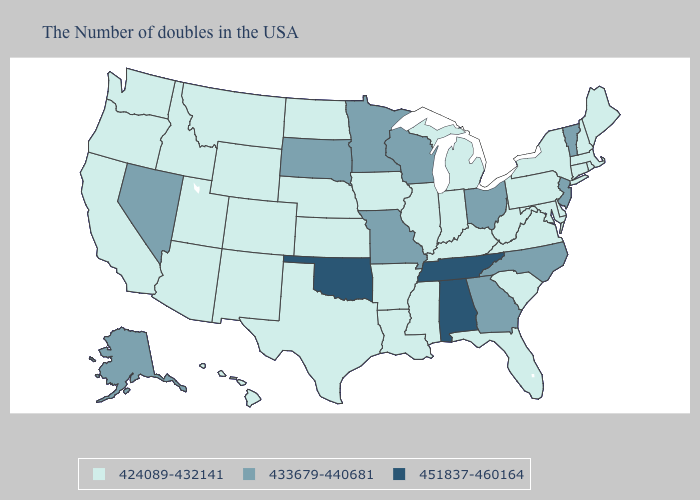Does Michigan have the highest value in the MidWest?
Give a very brief answer. No. What is the lowest value in the USA?
Quick response, please. 424089-432141. Name the states that have a value in the range 424089-432141?
Be succinct. Maine, Massachusetts, Rhode Island, New Hampshire, Connecticut, New York, Delaware, Maryland, Pennsylvania, Virginia, South Carolina, West Virginia, Florida, Michigan, Kentucky, Indiana, Illinois, Mississippi, Louisiana, Arkansas, Iowa, Kansas, Nebraska, Texas, North Dakota, Wyoming, Colorado, New Mexico, Utah, Montana, Arizona, Idaho, California, Washington, Oregon, Hawaii. What is the highest value in the USA?
Quick response, please. 451837-460164. What is the lowest value in the USA?
Be succinct. 424089-432141. What is the value of Alaska?
Short answer required. 433679-440681. Does Rhode Island have the highest value in the Northeast?
Keep it brief. No. Name the states that have a value in the range 433679-440681?
Quick response, please. Vermont, New Jersey, North Carolina, Ohio, Georgia, Wisconsin, Missouri, Minnesota, South Dakota, Nevada, Alaska. Which states have the lowest value in the West?
Quick response, please. Wyoming, Colorado, New Mexico, Utah, Montana, Arizona, Idaho, California, Washington, Oregon, Hawaii. How many symbols are there in the legend?
Answer briefly. 3. Does Wisconsin have a lower value than Oklahoma?
Keep it brief. Yes. Name the states that have a value in the range 451837-460164?
Give a very brief answer. Alabama, Tennessee, Oklahoma. Which states have the highest value in the USA?
Short answer required. Alabama, Tennessee, Oklahoma. 